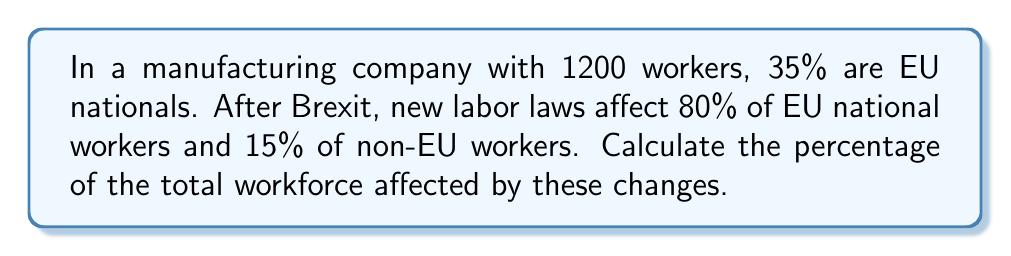What is the answer to this math problem? Let's approach this step-by-step:

1) First, let's calculate the number of EU and non-EU workers:
   EU workers: $1200 \times 35\% = 1200 \times 0.35 = 420$
   Non-EU workers: $1200 - 420 = 780$

2) Now, let's calculate the number of affected workers in each group:
   Affected EU workers: $420 \times 80\% = 420 \times 0.80 = 336$
   Affected non-EU workers: $780 \times 15\% = 780 \times 0.15 = 117$

3) Total number of affected workers:
   $336 + 117 = 453$

4) To calculate the percentage of the total workforce affected:
   $$\text{Percentage affected} = \frac{\text{Number affected}}{\text{Total workforce}} \times 100\%$$
   $$= \frac{453}{1200} \times 100\% = 0.3775 \times 100\% = 37.75\%$$

Therefore, 37.75% of the total workforce is affected by the changes in labor laws post-Brexit.
Answer: 37.75% 